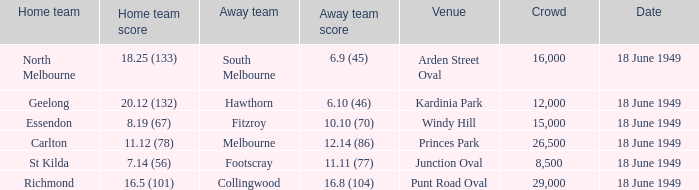12 (132)? 6.10 (46). 